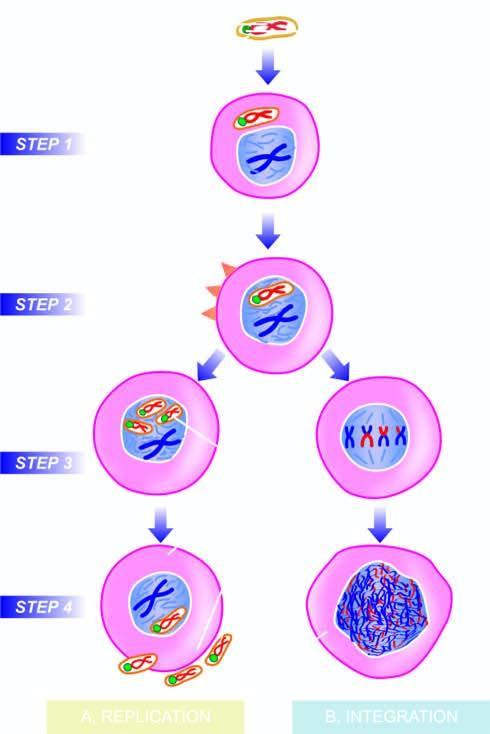what invades the host cell?
Answer the question using a single word or phrase. Dna virus 